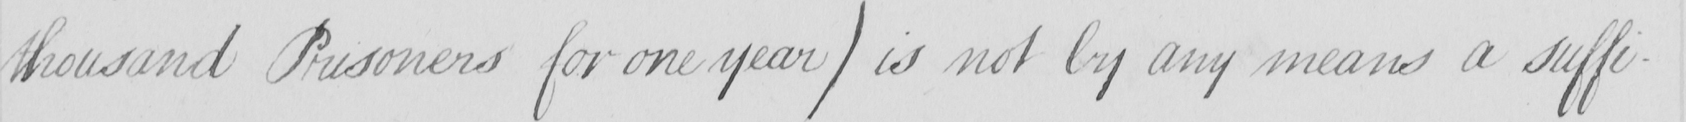What text is written in this handwritten line? thousand Prisoners for one year )  is not by any means a suffi- 